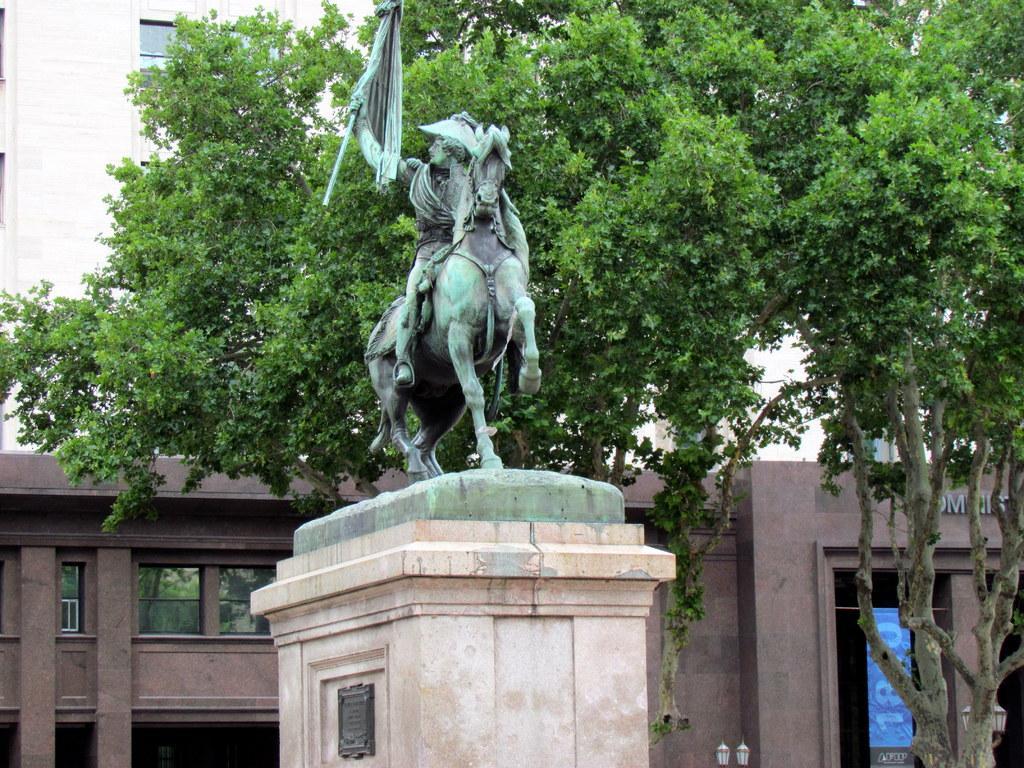Can you describe this image briefly? There is a sculpture in front of an organisation and beside the sculpture there is a huge tree and behind the tree there is a big building with a lot of windows. 